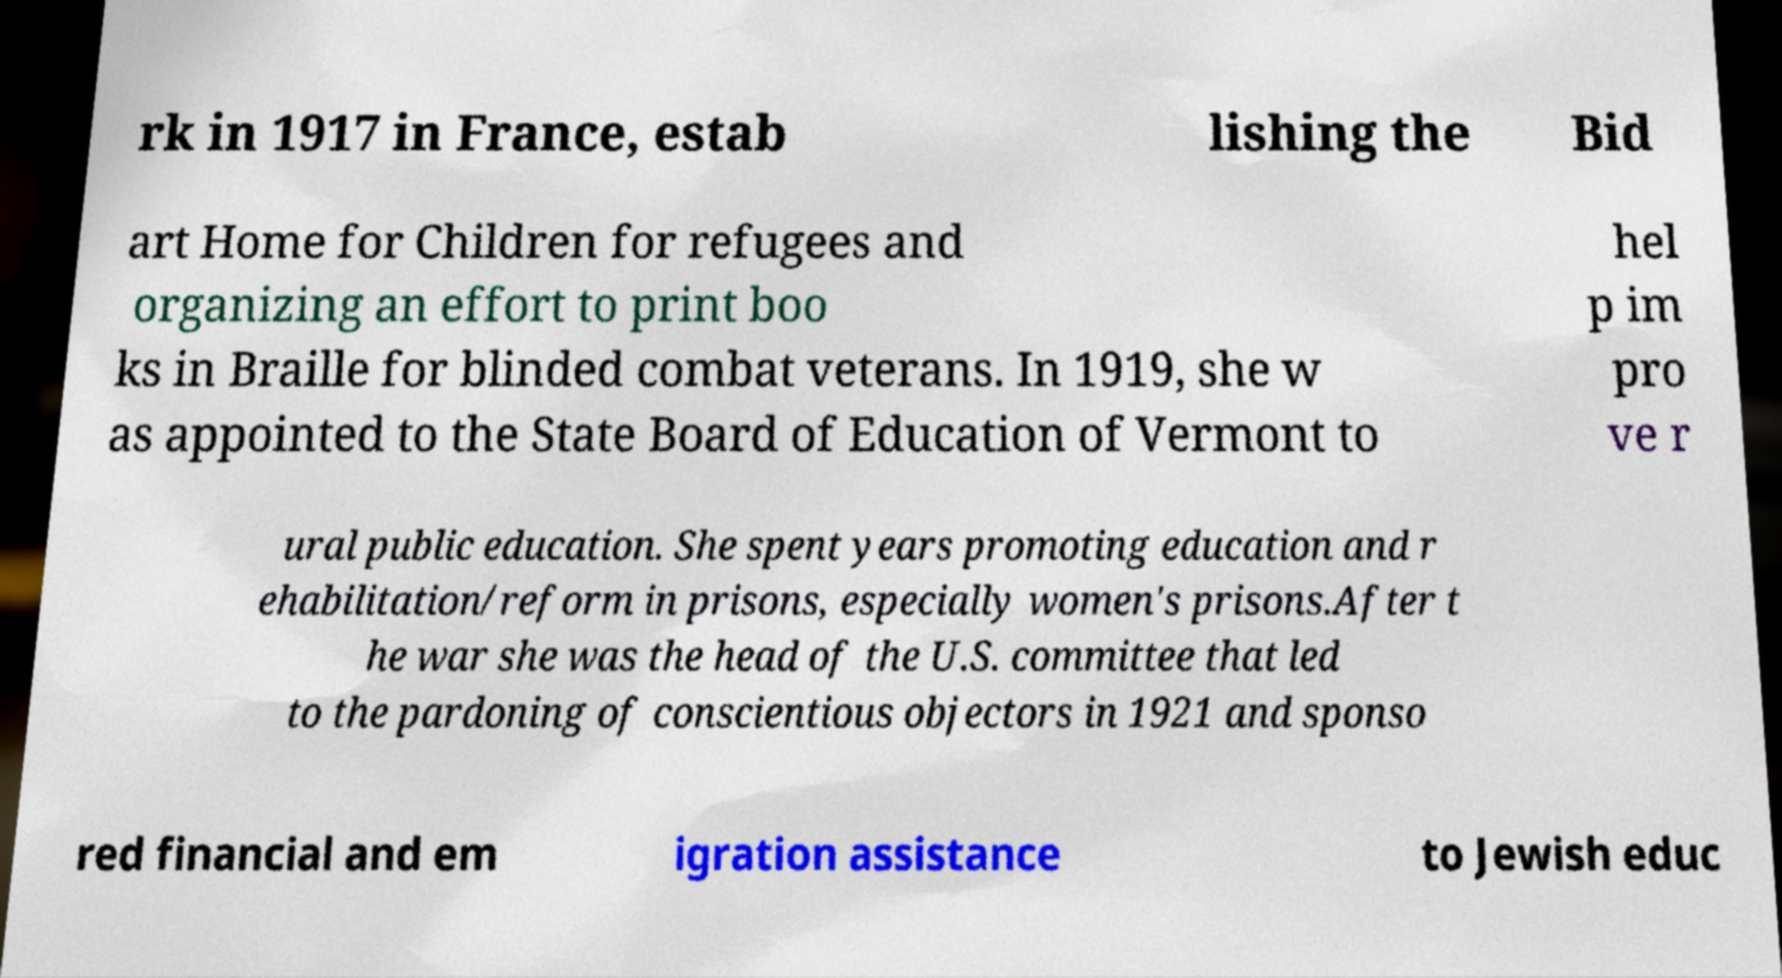Can you read and provide the text displayed in the image?This photo seems to have some interesting text. Can you extract and type it out for me? rk in 1917 in France, estab lishing the Bid art Home for Children for refugees and organizing an effort to print boo ks in Braille for blinded combat veterans. In 1919, she w as appointed to the State Board of Education of Vermont to hel p im pro ve r ural public education. She spent years promoting education and r ehabilitation/reform in prisons, especially women's prisons.After t he war she was the head of the U.S. committee that led to the pardoning of conscientious objectors in 1921 and sponso red financial and em igration assistance to Jewish educ 